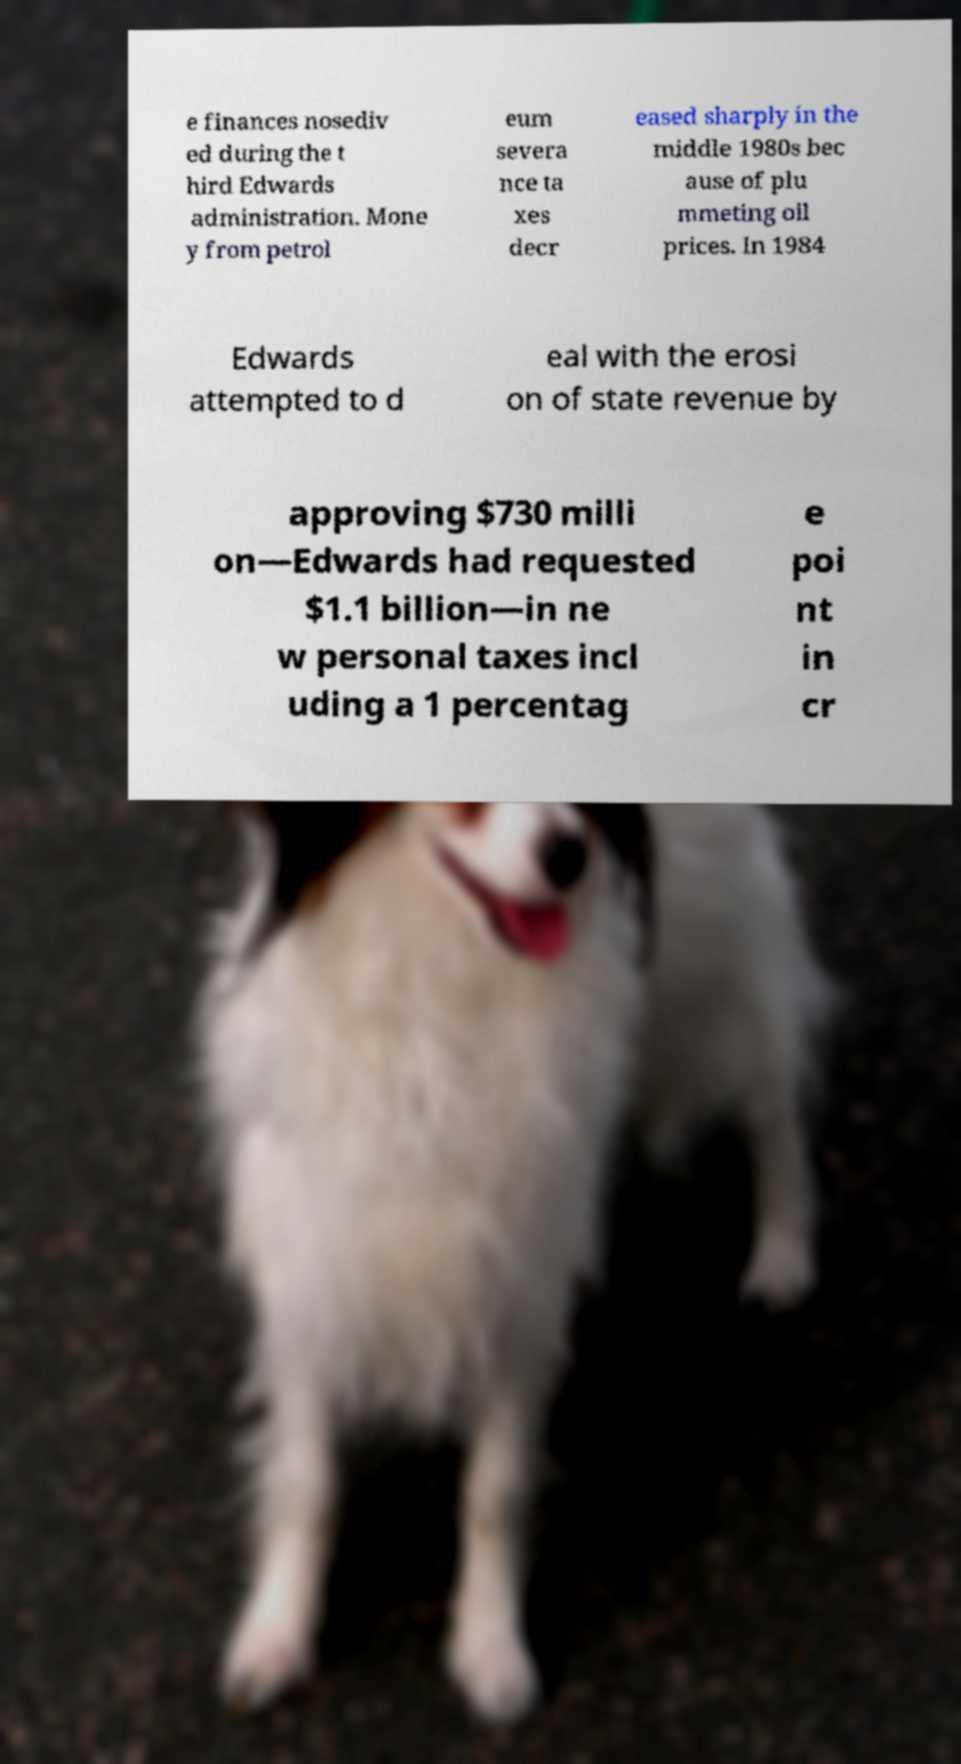Could you assist in decoding the text presented in this image and type it out clearly? e finances nosediv ed during the t hird Edwards administration. Mone y from petrol eum severa nce ta xes decr eased sharply in the middle 1980s bec ause of plu mmeting oil prices. In 1984 Edwards attempted to d eal with the erosi on of state revenue by approving $730 milli on—Edwards had requested $1.1 billion—in ne w personal taxes incl uding a 1 percentag e poi nt in cr 